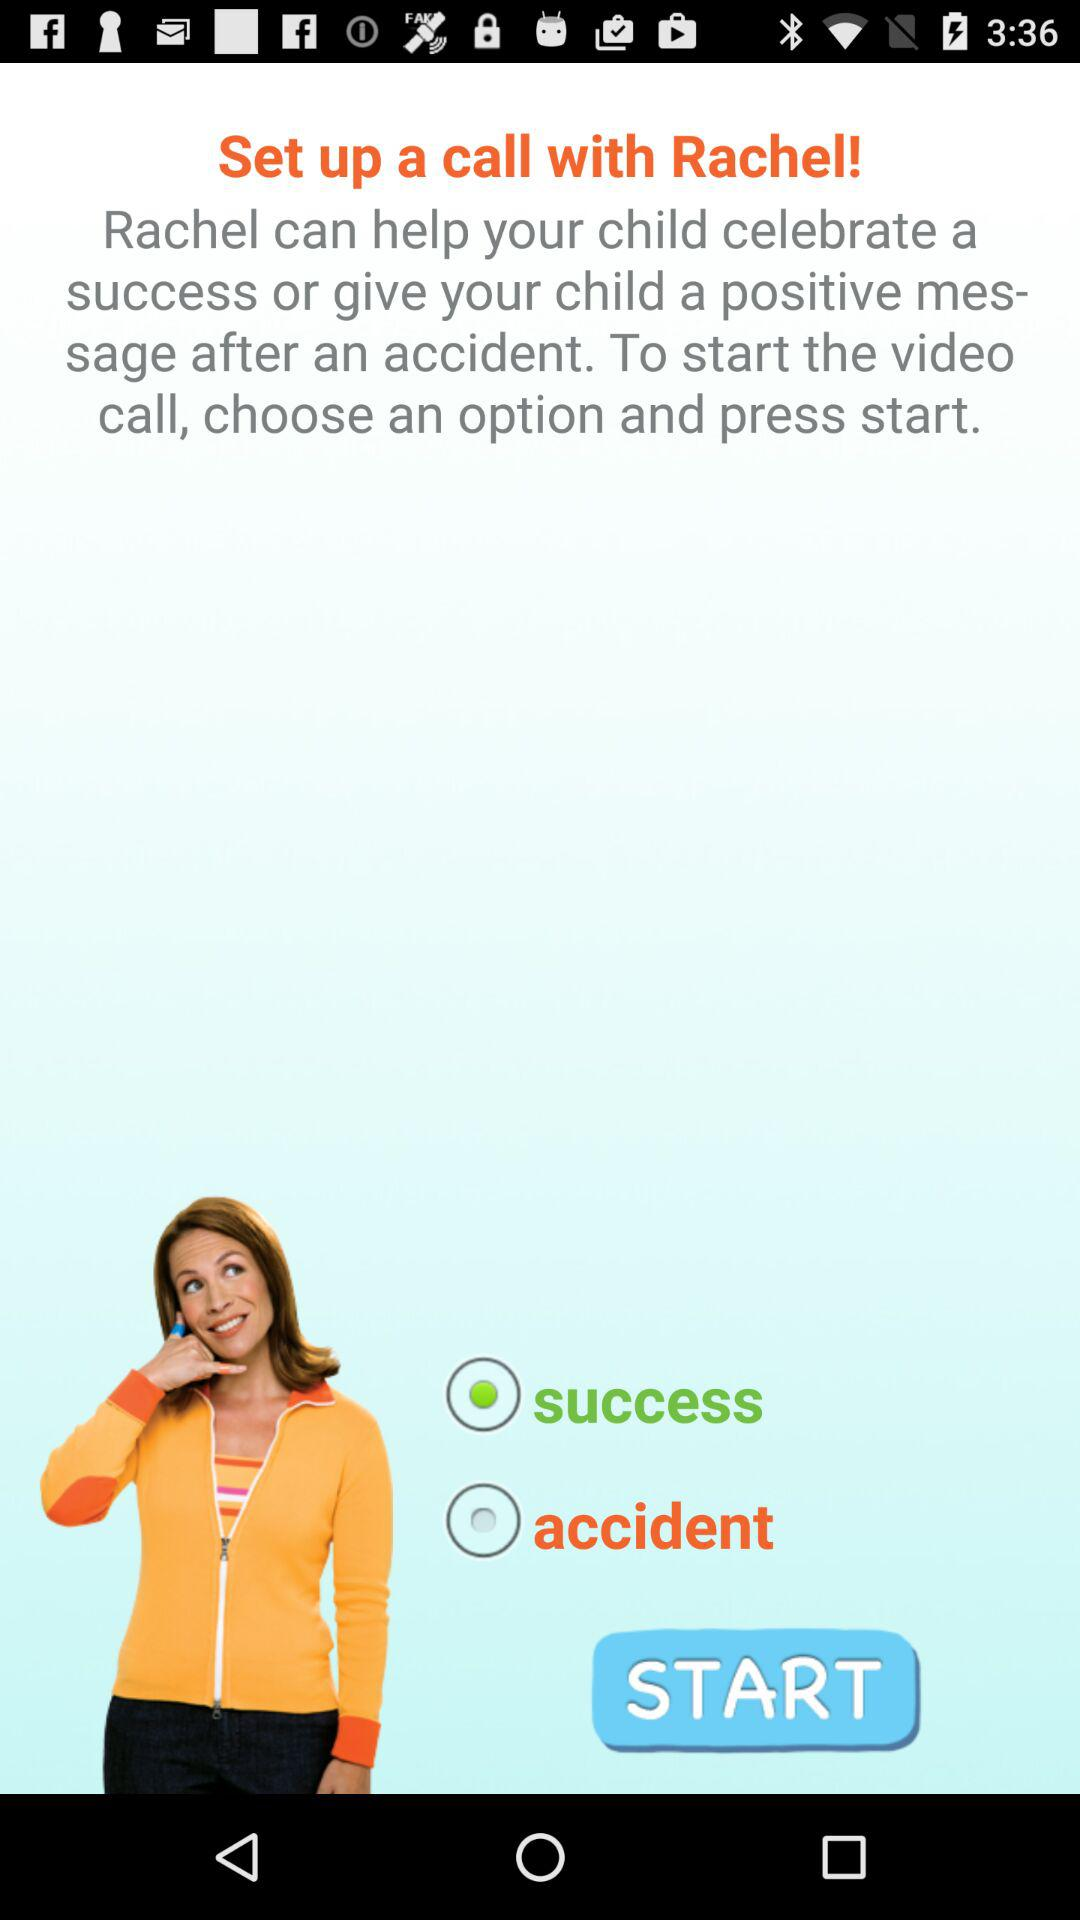How many options are there for the user to choose from?
Answer the question using a single word or phrase. 2 